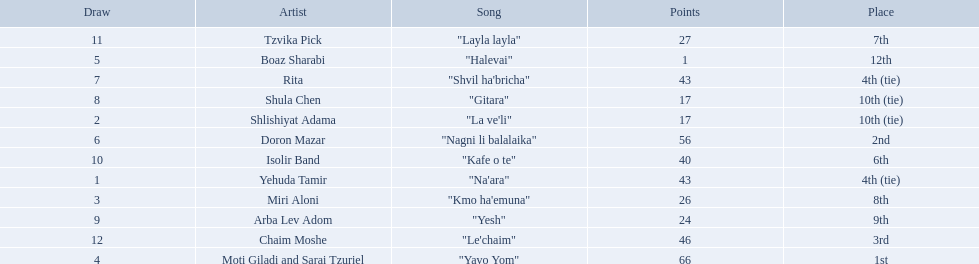Who were all the artists at the contest? Yehuda Tamir, Shlishiyat Adama, Miri Aloni, Moti Giladi and Sarai Tzuriel, Boaz Sharabi, Doron Mazar, Rita, Shula Chen, Arba Lev Adom, Isolir Band, Tzvika Pick, Chaim Moshe. What were their point totals? 43, 17, 26, 66, 1, 56, 43, 17, 24, 40, 27, 46. Of these, which is the least amount of points? 1. Which artists received this point total? Boaz Sharabi. 